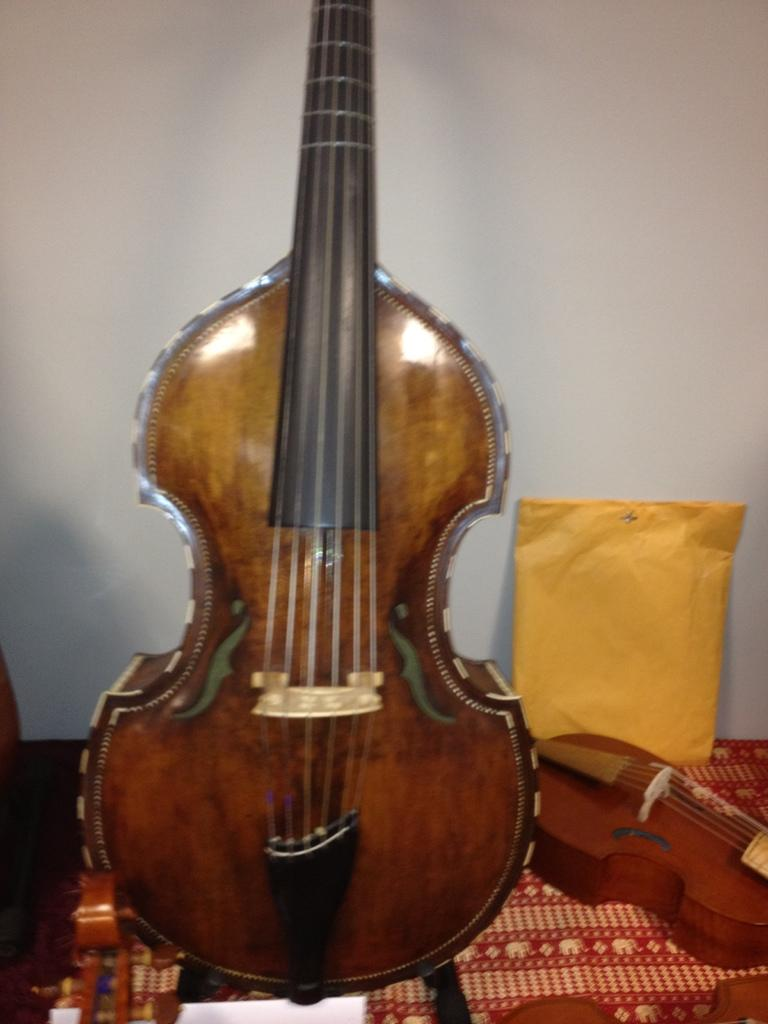What musical instruments are present in the image? There is a guitar and a violin in the image. How are the instruments arranged on the table? The violin is beside the guitar. What is located behind the violin? There is a packet behind the violin. Where is this scene taking place? All these objects are on a table, and there is a white wall in the background of the image. What type of can is visible in the image? There is no can present in the image. What topic are the guitar and violin discussing in the image? Musical instruments, such as guitars and violins, do not engage in discussions. 